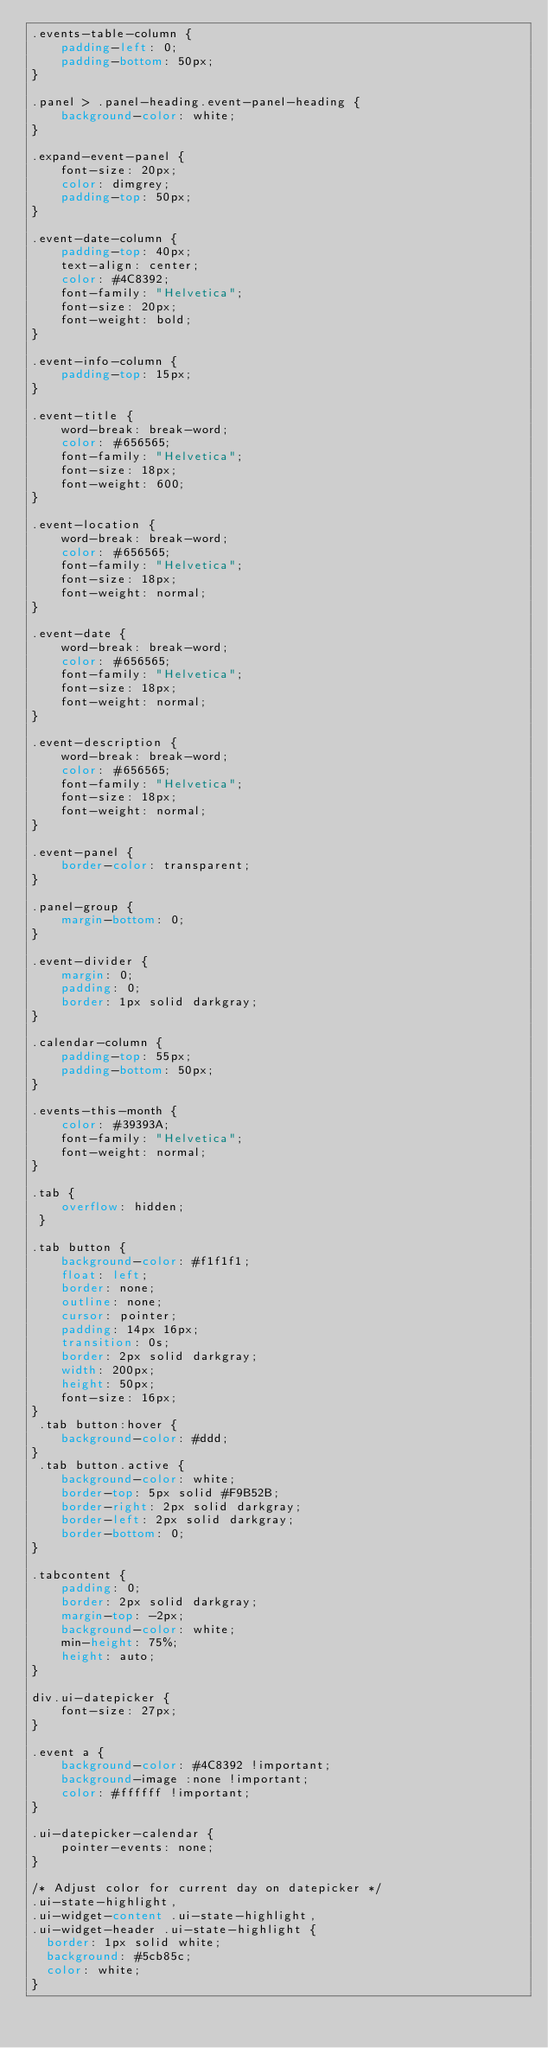Convert code to text. <code><loc_0><loc_0><loc_500><loc_500><_CSS_>.events-table-column {
    padding-left: 0;
    padding-bottom: 50px;
}

.panel > .panel-heading.event-panel-heading {
    background-color: white;
}

.expand-event-panel {
    font-size: 20px;
    color: dimgrey;
    padding-top: 50px;
}

.event-date-column {
    padding-top: 40px;
    text-align: center;
    color: #4C8392;
    font-family: "Helvetica";
    font-size: 20px;
    font-weight: bold;
}

.event-info-column {
    padding-top: 15px;
}

.event-title {
    word-break: break-word;
    color: #656565;
    font-family: "Helvetica";
    font-size: 18px;
    font-weight: 600;
}

.event-location {
    word-break: break-word;
    color: #656565;
    font-family: "Helvetica";
    font-size: 18px;
    font-weight: normal;
}

.event-date {
    word-break: break-word;
    color: #656565;
    font-family: "Helvetica";
    font-size: 18px;
    font-weight: normal;
}

.event-description {
    word-break: break-word;
    color: #656565;
    font-family: "Helvetica";
    font-size: 18px;
    font-weight: normal;
}

.event-panel {
    border-color: transparent;
}

.panel-group {
    margin-bottom: 0;
}

.event-divider {
    margin: 0;
    padding: 0;
    border: 1px solid darkgray;
}

.calendar-column {
    padding-top: 55px;
    padding-bottom: 50px;
}

.events-this-month {
    color: #39393A;
    font-family: "Helvetica";
    font-weight: normal;
}

.tab {
    overflow: hidden;
 }

.tab button {
    background-color: #f1f1f1;
    float: left;
    border: none;
    outline: none;
    cursor: pointer;
    padding: 14px 16px;
    transition: 0s;
    border: 2px solid darkgray;
    width: 200px;
    height: 50px;
    font-size: 16px;
}
 .tab button:hover {
    background-color: #ddd;
}
 .tab button.active {
    background-color: white;
    border-top: 5px solid #F9B52B;
    border-right: 2px solid darkgray;
    border-left: 2px solid darkgray;
    border-bottom: 0;
}

.tabcontent {
    padding: 0;
    border: 2px solid darkgray;
    margin-top: -2px;
    background-color: white;
    min-height: 75%;
    height: auto;
}

div.ui-datepicker {
    font-size: 27px;
}

.event a {
    background-color: #4C8392 !important;
    background-image :none !important;
    color: #ffffff !important;
}

.ui-datepicker-calendar {
    pointer-events: none;
}

/* Adjust color for current day on datepicker */
.ui-state-highlight,
.ui-widget-content .ui-state-highlight,
.ui-widget-header .ui-state-highlight {
	border: 1px solid white;
	background: #5cb85c;
	color: white;
}</code> 